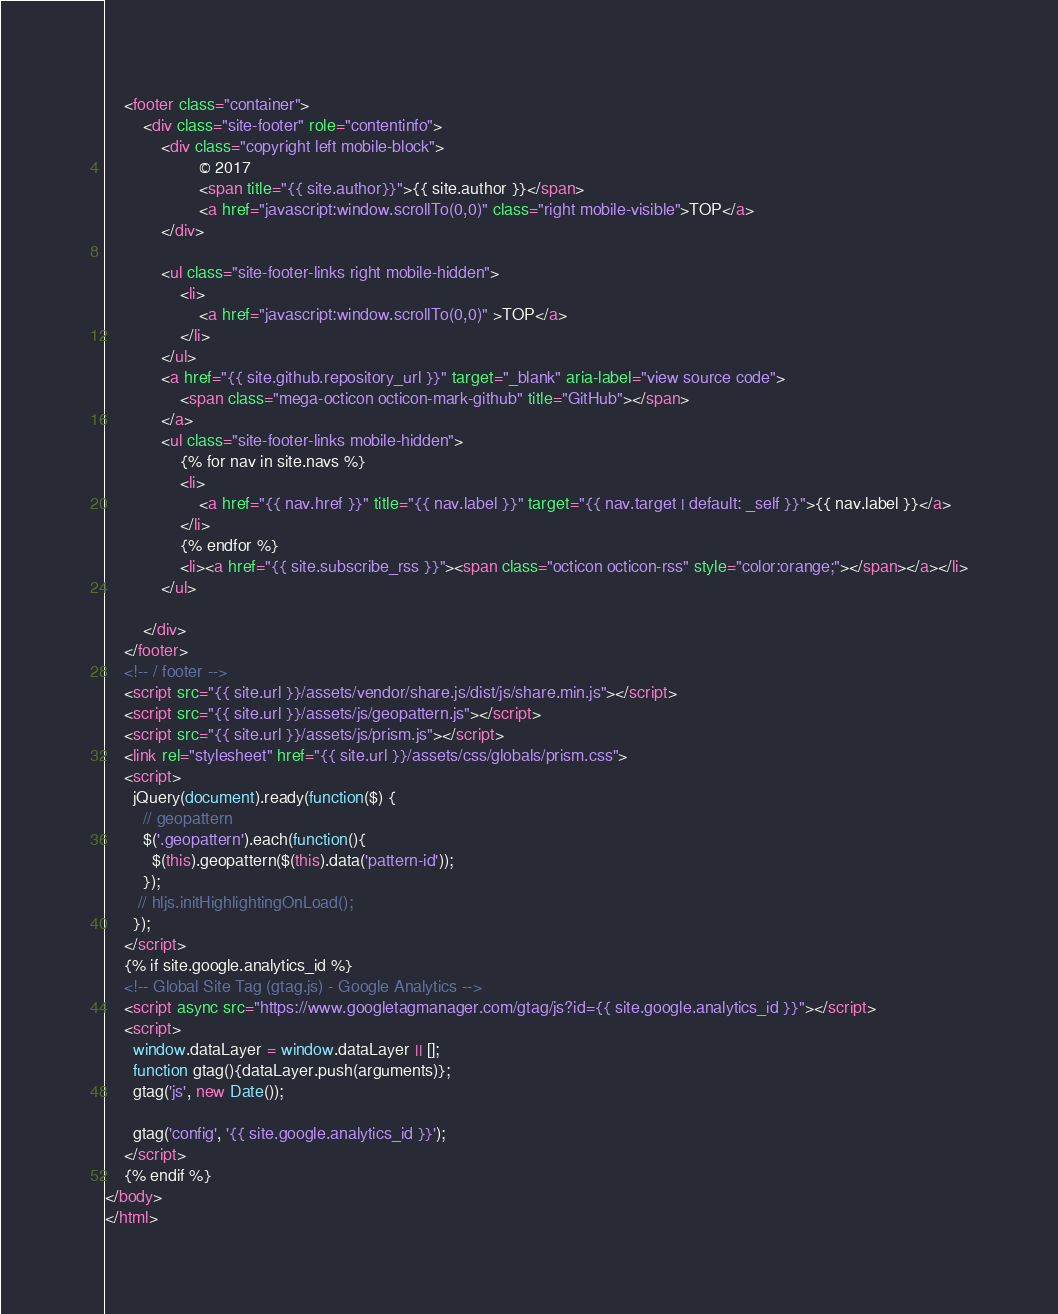Convert code to text. <code><loc_0><loc_0><loc_500><loc_500><_HTML_>    <footer class="container">
        <div class="site-footer" role="contentinfo">
            <div class="copyright left mobile-block">
                    © 2017
                    <span title="{{ site.author}}">{{ site.author }}</span>
                    <a href="javascript:window.scrollTo(0,0)" class="right mobile-visible">TOP</a>
            </div>

            <ul class="site-footer-links right mobile-hidden">
                <li>
                    <a href="javascript:window.scrollTo(0,0)" >TOP</a>
                </li>
            </ul>
            <a href="{{ site.github.repository_url }}" target="_blank" aria-label="view source code">
                <span class="mega-octicon octicon-mark-github" title="GitHub"></span>
            </a>
            <ul class="site-footer-links mobile-hidden">
                {% for nav in site.navs %}
                <li>
                    <a href="{{ nav.href }}" title="{{ nav.label }}" target="{{ nav.target | default: _self }}">{{ nav.label }}</a>
                </li>
                {% endfor %}
                <li><a href="{{ site.subscribe_rss }}"><span class="octicon octicon-rss" style="color:orange;"></span></a></li>
            </ul>

        </div>
    </footer>
    <!-- / footer -->
    <script src="{{ site.url }}/assets/vendor/share.js/dist/js/share.min.js"></script>
    <script src="{{ site.url }}/assets/js/geopattern.js"></script>
    <script src="{{ site.url }}/assets/js/prism.js"></script>
    <link rel="stylesheet" href="{{ site.url }}/assets/css/globals/prism.css">
    <script>
      jQuery(document).ready(function($) {
        // geopattern
        $('.geopattern').each(function(){
          $(this).geopattern($(this).data('pattern-id'));
        });
       // hljs.initHighlightingOnLoad();
      });
    </script>
    {% if site.google.analytics_id %}
    <!-- Global Site Tag (gtag.js) - Google Analytics -->
    <script async src="https://www.googletagmanager.com/gtag/js?id={{ site.google.analytics_id }}"></script>
    <script>
      window.dataLayer = window.dataLayer || [];
      function gtag(){dataLayer.push(arguments)};
      gtag('js', new Date());

      gtag('config', '{{ site.google.analytics_id }}');
    </script>
    {% endif %}
</body>
</html>
</code> 